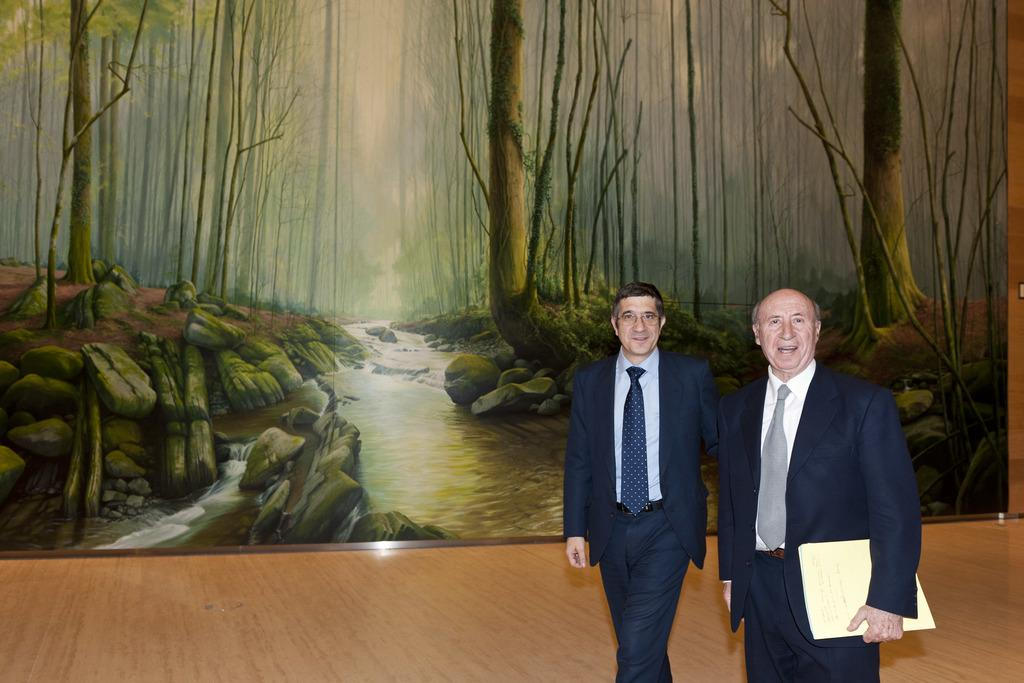How many men are present in the image? There are two men in the image. What are the men wearing? Both men are wearing blue suits. What is one of the men holding? One of the men is holding a file. What can be seen under the men's feet in the image? There is a floor visible in the image. What is in the background of the image? There is a poster on the wall in the background. How many ladybugs can be seen on the poster in the image? There are no ladybugs visible in the image, nor is there a poster with ladybugs on it. 